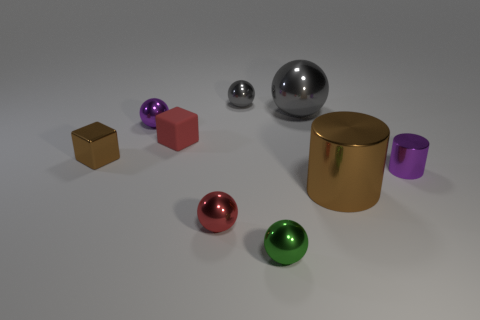Reflect upon the arrangement of the objects. Does it suggest anything to you? The arrangement of the objects could evoke a sense of balance and deliberate placement, possibly suggesting an artistic or aesthetic intention. Each object is spaced out evenly, which might imply a design that values symmetry and composition. 